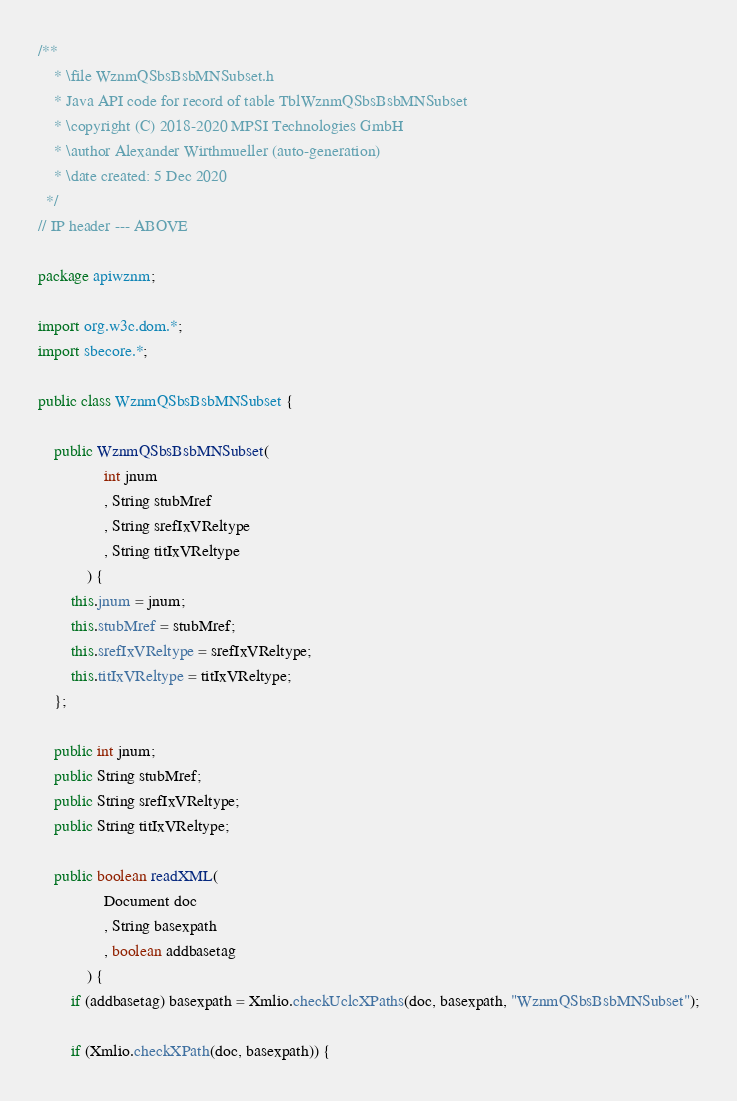Convert code to text. <code><loc_0><loc_0><loc_500><loc_500><_Java_>/**
	* \file WznmQSbsBsbMNSubset.h
	* Java API code for record of table TblWznmQSbsBsbMNSubset
	* \copyright (C) 2018-2020 MPSI Technologies GmbH
	* \author Alexander Wirthmueller (auto-generation)
	* \date created: 5 Dec 2020
  */
// IP header --- ABOVE

package apiwznm;

import org.w3c.dom.*;
import sbecore.*;

public class WznmQSbsBsbMNSubset {
	
	public WznmQSbsBsbMNSubset(
				int jnum
				, String stubMref
				, String srefIxVReltype
				, String titIxVReltype
			) {
		this.jnum = jnum;
		this.stubMref = stubMref;
		this.srefIxVReltype = srefIxVReltype;
		this.titIxVReltype = titIxVReltype;
	};

	public int jnum;
	public String stubMref;
	public String srefIxVReltype;
	public String titIxVReltype;
	
	public boolean readXML(
				Document doc
				, String basexpath
				, boolean addbasetag
			) {
		if (addbasetag) basexpath = Xmlio.checkUclcXPaths(doc, basexpath, "WznmQSbsBsbMNSubset");

		if (Xmlio.checkXPath(doc, basexpath)) {</code> 